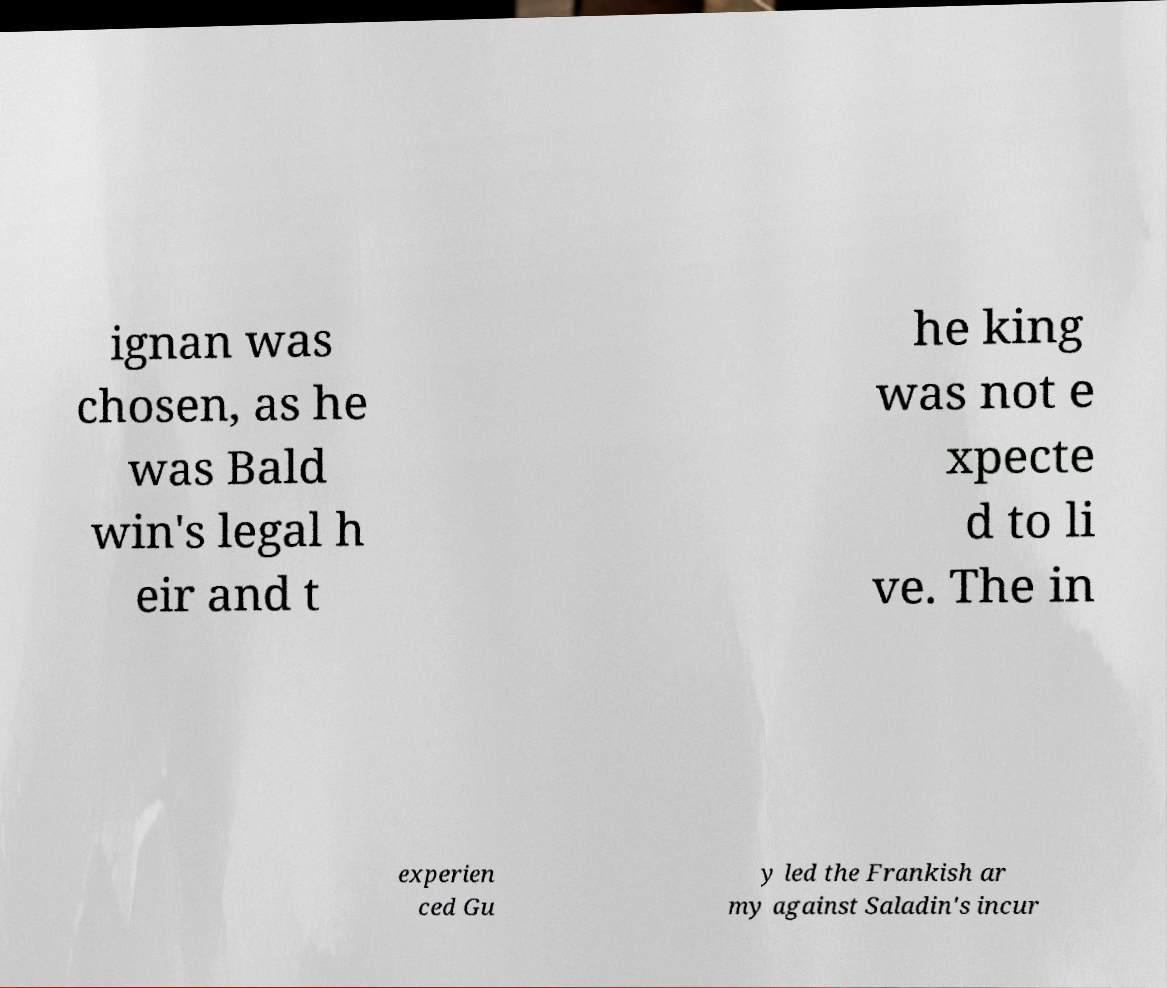Please identify and transcribe the text found in this image. ignan was chosen, as he was Bald win's legal h eir and t he king was not e xpecte d to li ve. The in experien ced Gu y led the Frankish ar my against Saladin's incur 